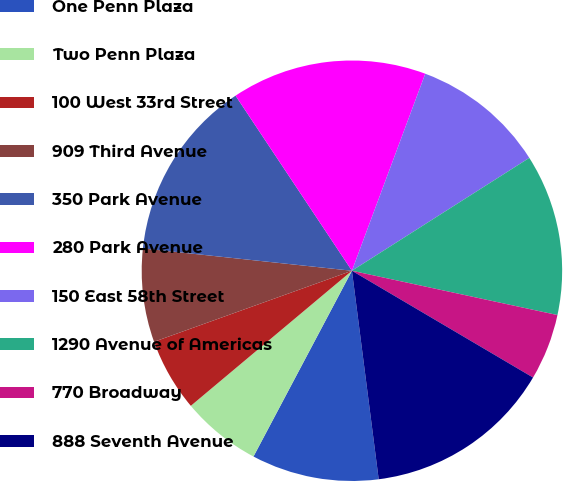Convert chart. <chart><loc_0><loc_0><loc_500><loc_500><pie_chart><fcel>One Penn Plaza<fcel>Two Penn Plaza<fcel>100 West 33rd Street<fcel>909 Third Avenue<fcel>350 Park Avenue<fcel>280 Park Avenue<fcel>150 East 58th Street<fcel>1290 Avenue of Americas<fcel>770 Broadway<fcel>888 Seventh Avenue<nl><fcel>9.79%<fcel>6.14%<fcel>5.62%<fcel>7.18%<fcel>13.97%<fcel>15.01%<fcel>10.31%<fcel>12.4%<fcel>5.1%<fcel>14.49%<nl></chart> 